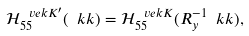<formula> <loc_0><loc_0><loc_500><loc_500>\mathcal { H } _ { 5 5 } ^ { \ v e k { K } ^ { \prime } } ( \ k k ) = \mathcal { H } _ { 5 5 } ^ { \ v e k { K } } ( R _ { y } ^ { - 1 } \ k k ) ,</formula> 